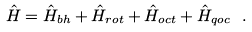Convert formula to latex. <formula><loc_0><loc_0><loc_500><loc_500>\hat { H } = \hat { H } _ { b h } + \hat { H } _ { r o t } + \hat { H } _ { o c t } + \hat { H } _ { q o c } \ .</formula> 